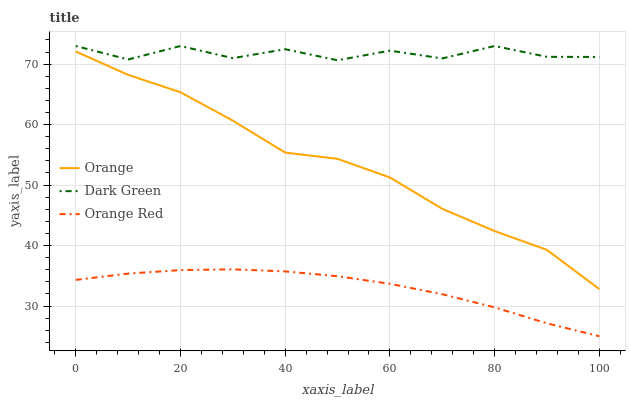Does Orange Red have the minimum area under the curve?
Answer yes or no. Yes. Does Dark Green have the maximum area under the curve?
Answer yes or no. Yes. Does Dark Green have the minimum area under the curve?
Answer yes or no. No. Does Orange Red have the maximum area under the curve?
Answer yes or no. No. Is Orange Red the smoothest?
Answer yes or no. Yes. Is Dark Green the roughest?
Answer yes or no. Yes. Is Dark Green the smoothest?
Answer yes or no. No. Is Orange Red the roughest?
Answer yes or no. No. Does Orange Red have the lowest value?
Answer yes or no. Yes. Does Dark Green have the lowest value?
Answer yes or no. No. Does Dark Green have the highest value?
Answer yes or no. Yes. Does Orange Red have the highest value?
Answer yes or no. No. Is Orange less than Dark Green?
Answer yes or no. Yes. Is Dark Green greater than Orange Red?
Answer yes or no. Yes. Does Orange intersect Dark Green?
Answer yes or no. No. 